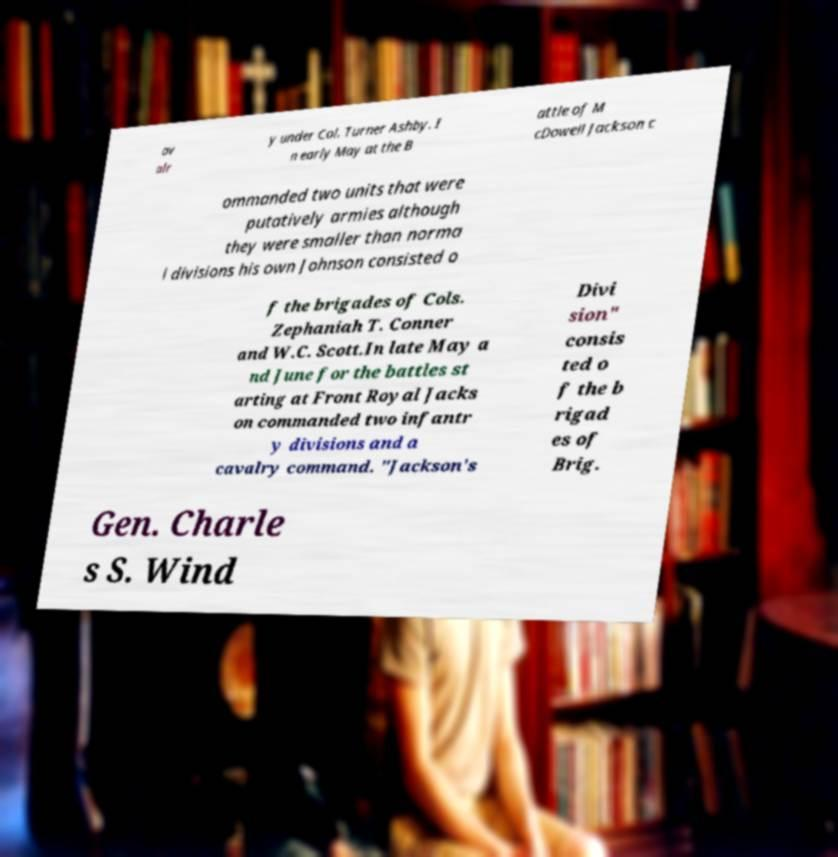Can you read and provide the text displayed in the image?This photo seems to have some interesting text. Can you extract and type it out for me? av alr y under Col. Turner Ashby. I n early May at the B attle of M cDowell Jackson c ommanded two units that were putatively armies although they were smaller than norma l divisions his own Johnson consisted o f the brigades of Cols. Zephaniah T. Conner and W.C. Scott.In late May a nd June for the battles st arting at Front Royal Jacks on commanded two infantr y divisions and a cavalry command. "Jackson's Divi sion" consis ted o f the b rigad es of Brig. Gen. Charle s S. Wind 